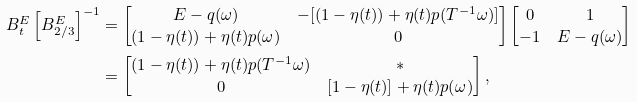<formula> <loc_0><loc_0><loc_500><loc_500>B _ { t } ^ { E } \left [ B _ { 2 / 3 } ^ { E } \right ] ^ { - 1 } & = \begin{bmatrix} E - q ( \omega ) & - [ ( 1 - \eta ( t ) ) + \eta ( t ) p ( T ^ { - 1 } \omega ) ] \\ ( 1 - \eta ( t ) ) + \eta ( t ) p ( \omega ) & 0 \end{bmatrix} \begin{bmatrix} 0 & 1 \\ - 1 & E - q ( \omega ) \end{bmatrix} \\ & = \begin{bmatrix} ( 1 - \eta ( t ) ) + \eta ( t ) p ( T ^ { - 1 } \omega ) & * \\ 0 & [ 1 - \eta ( t ) ] + \eta ( t ) p ( \omega ) \end{bmatrix} ,</formula> 